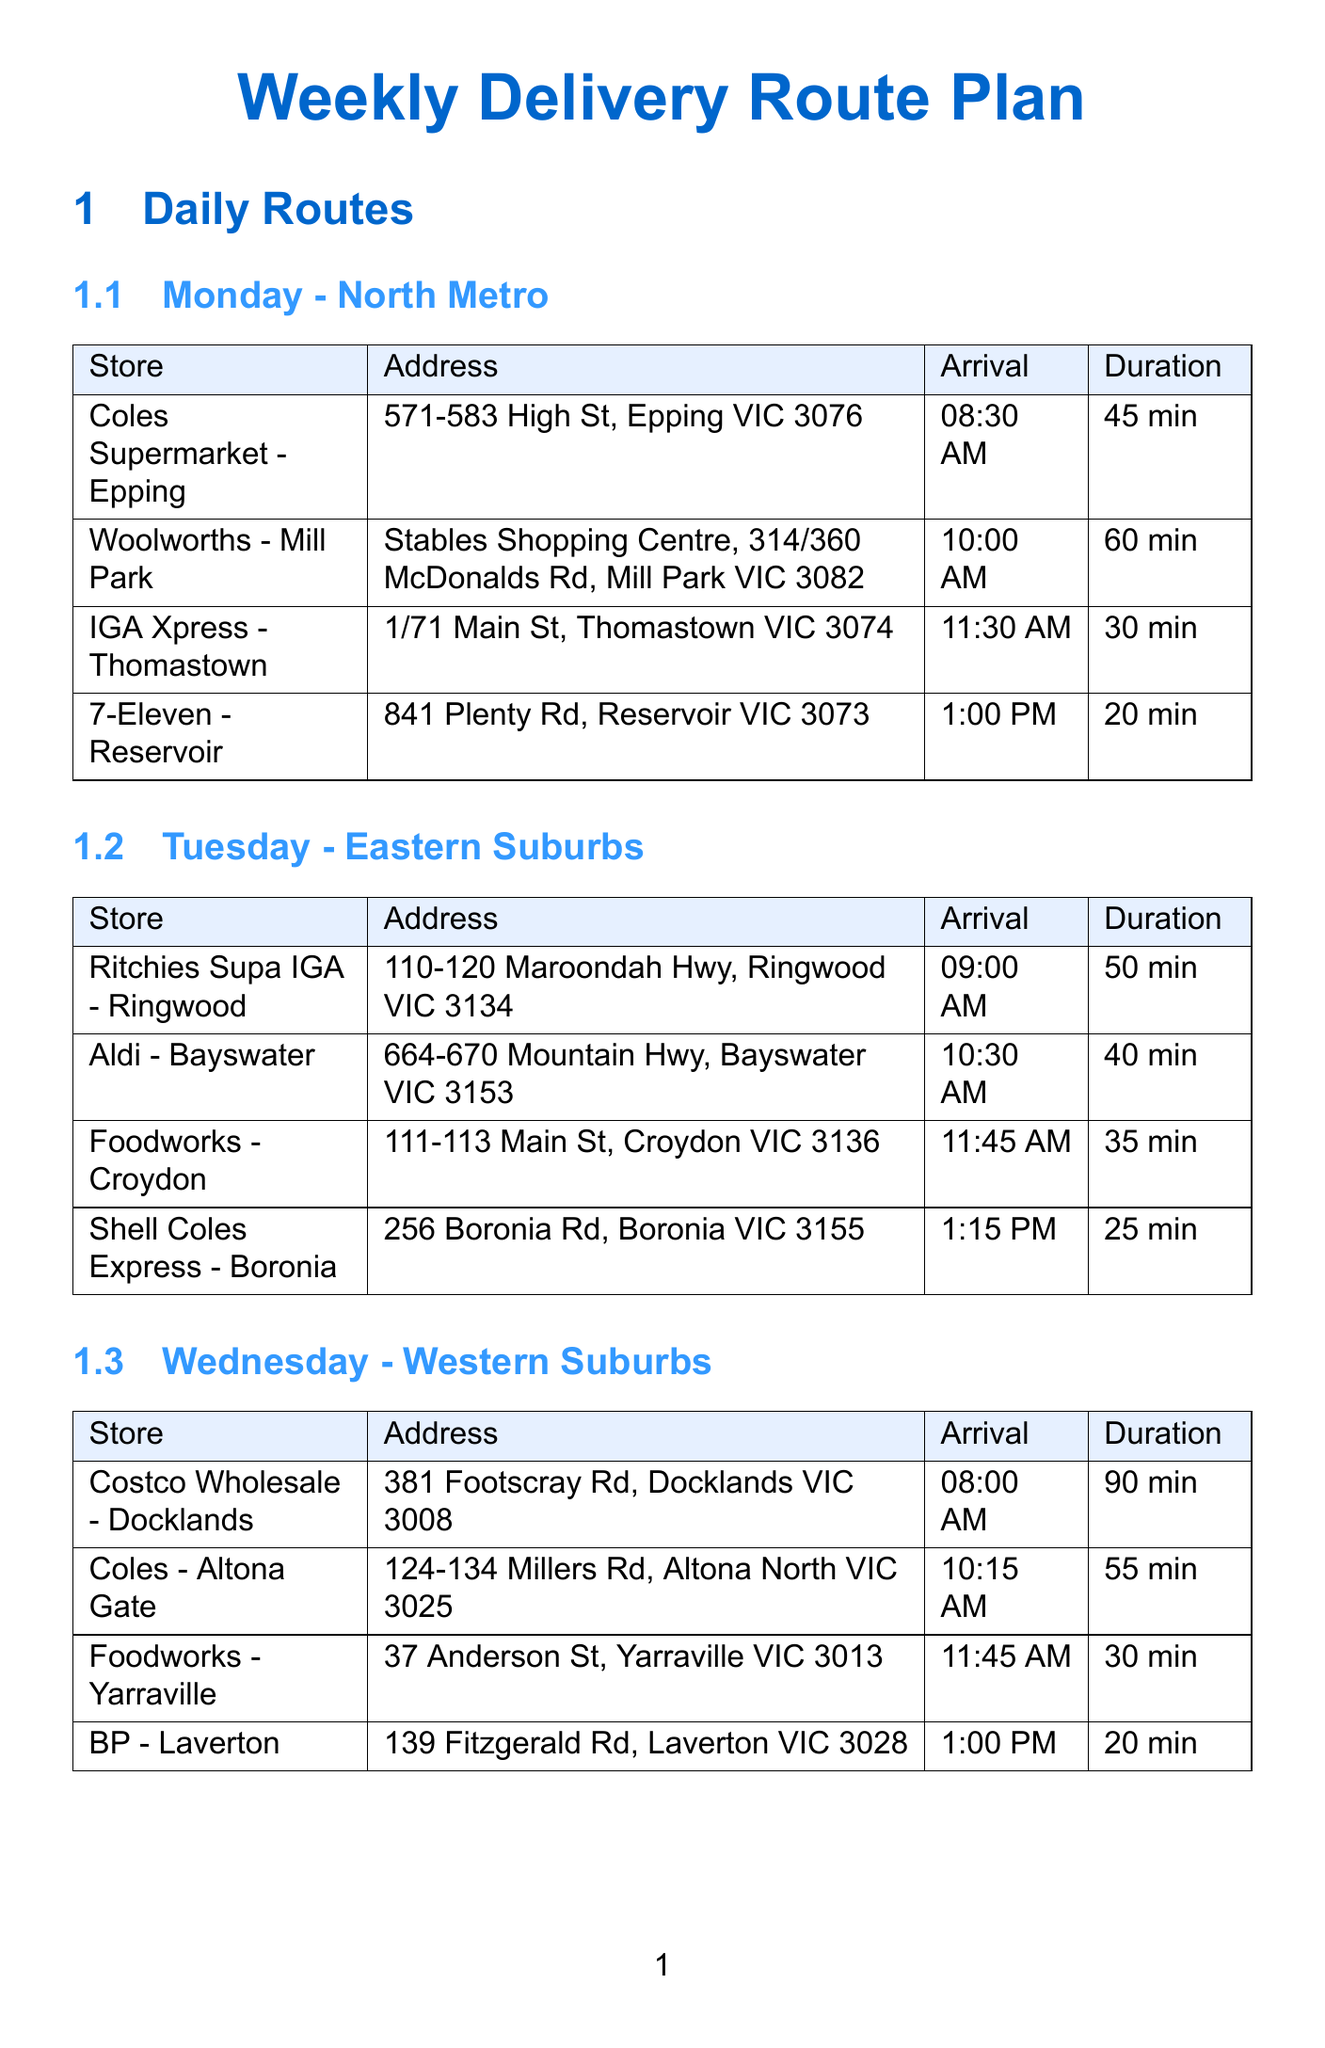what is the route for Monday? The document states that Monday's route is "North Metro".
Answer: North Metro how many stops are scheduled on Friday? The document lists four stops under Friday's schedule.
Answer: 4 what is the estimated arrival time at Woolworths - Chadstone on Thursday? The estimated arrival time for Woolworths - Chadstone is detailed in the schedule as 09:30 AM.
Answer: 09:30 AM what is the estimated duration for delivery at Costco Wholesale - Docklands? The document indicates that the estimated duration at Costco Wholesale - Docklands is 90 minutes.
Answer: 90 minutes which store is listed as the first stop on Tuesday? The first stop on Tuesday according to the document is Ritchies Supa IGA - Ringwood.
Answer: Ritchies Supa IGA - Ringwood how many pallets can the refrigerated truck carry? The document states that the refrigerated truck has a capacity of 10 pallets.
Answer: 10 pallets what is the address of IGA - Bentleigh? The address for IGA - Bentleigh is provided as "427-429 Centre Rd, Bentleigh VIC 3204" in the document.
Answer: 427-429 Centre Rd, Bentleigh VIC 3204 what is the phone number for the Customer Service department? The document lists the Customer Service phone number as 1800 123 456.
Answer: 1800 123 456 which store has the longest estimated delivery duration on Friday? The longest estimated delivery duration on Friday is for Queen Victoria Market at 120 minutes.
Answer: Queen Victoria Market 